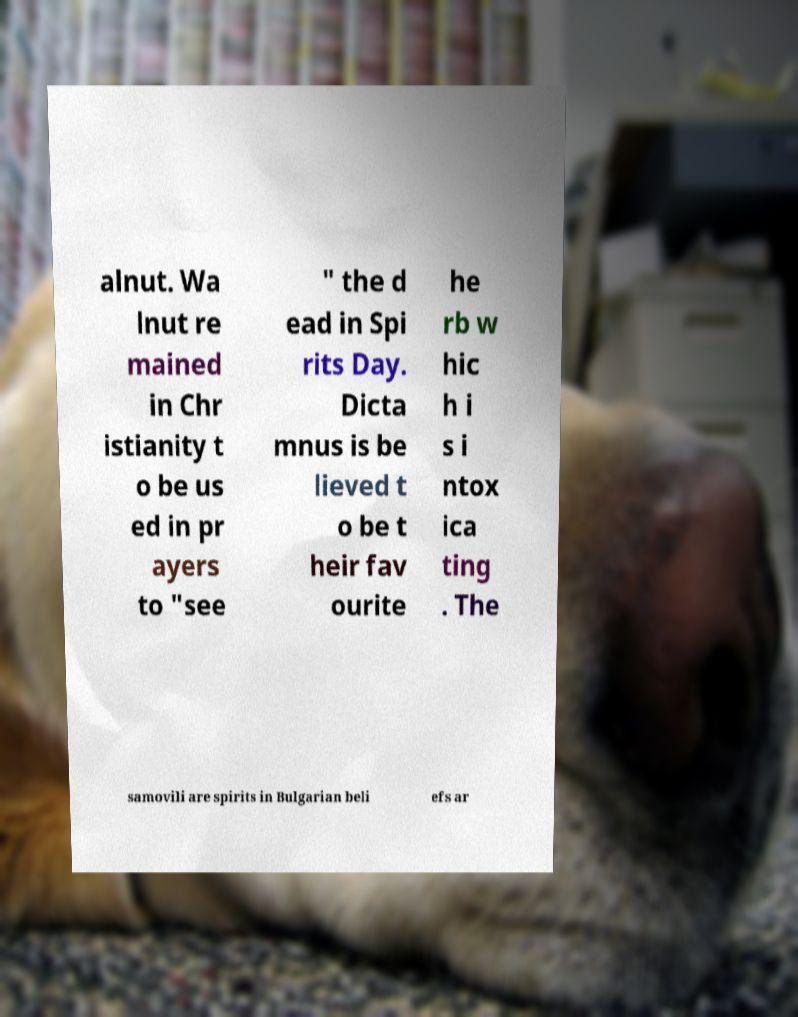Please read and relay the text visible in this image. What does it say? alnut. Wa lnut re mained in Chr istianity t o be us ed in pr ayers to "see " the d ead in Spi rits Day. Dicta mnus is be lieved t o be t heir fav ourite he rb w hic h i s i ntox ica ting . The samovili are spirits in Bulgarian beli efs ar 